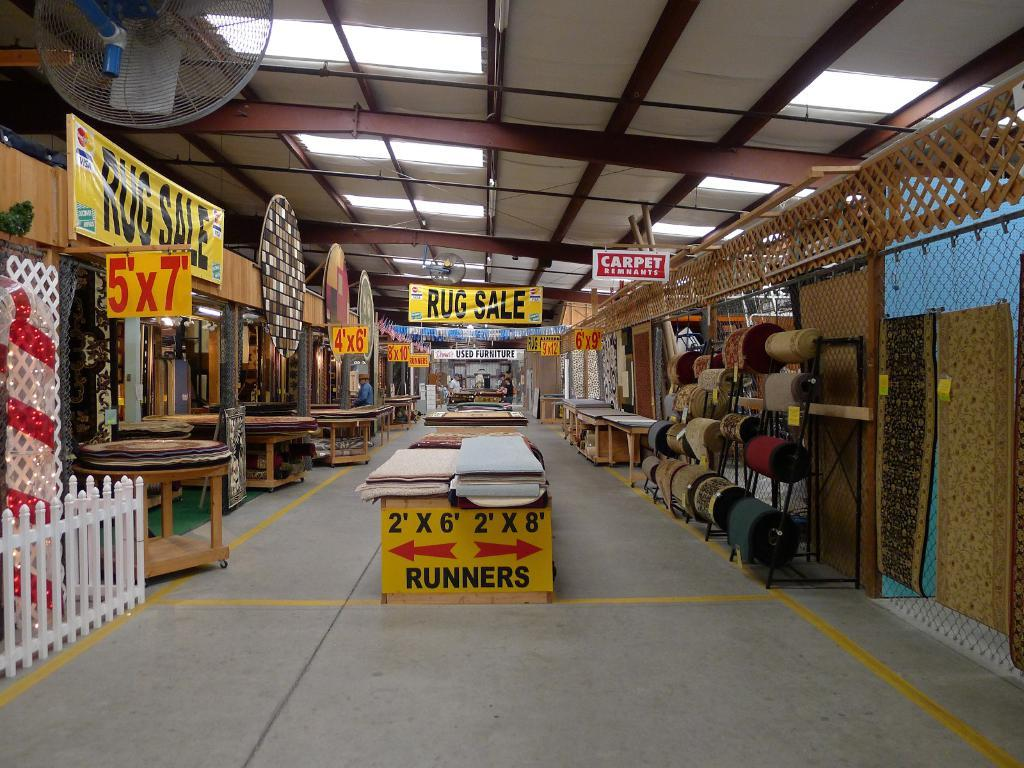<image>
Render a clear and concise summary of the photo. A sign at the front of an aisle explains where runners are at. 